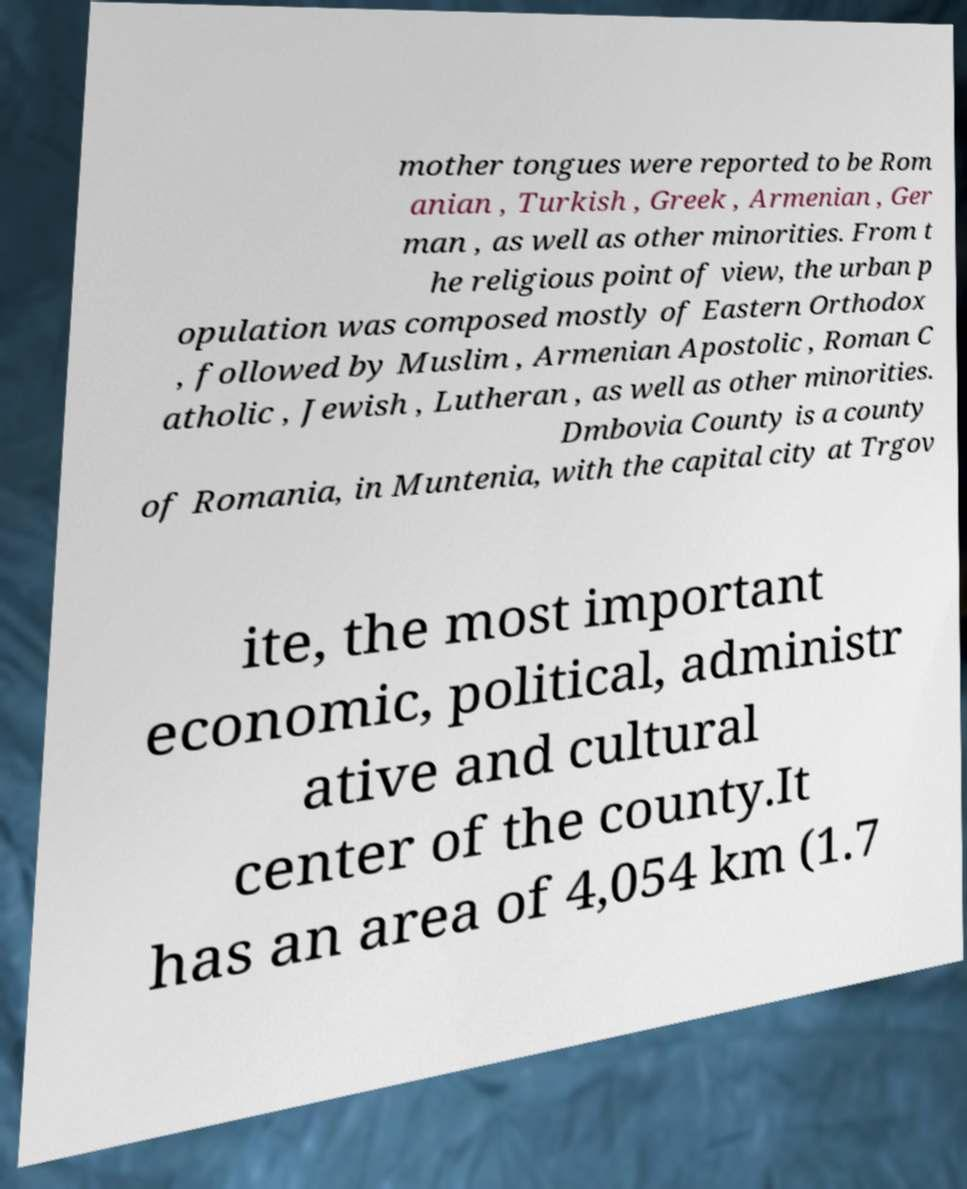Could you extract and type out the text from this image? mother tongues were reported to be Rom anian , Turkish , Greek , Armenian , Ger man , as well as other minorities. From t he religious point of view, the urban p opulation was composed mostly of Eastern Orthodox , followed by Muslim , Armenian Apostolic , Roman C atholic , Jewish , Lutheran , as well as other minorities. Dmbovia County is a county of Romania, in Muntenia, with the capital city at Trgov ite, the most important economic, political, administr ative and cultural center of the county.It has an area of 4,054 km (1.7 